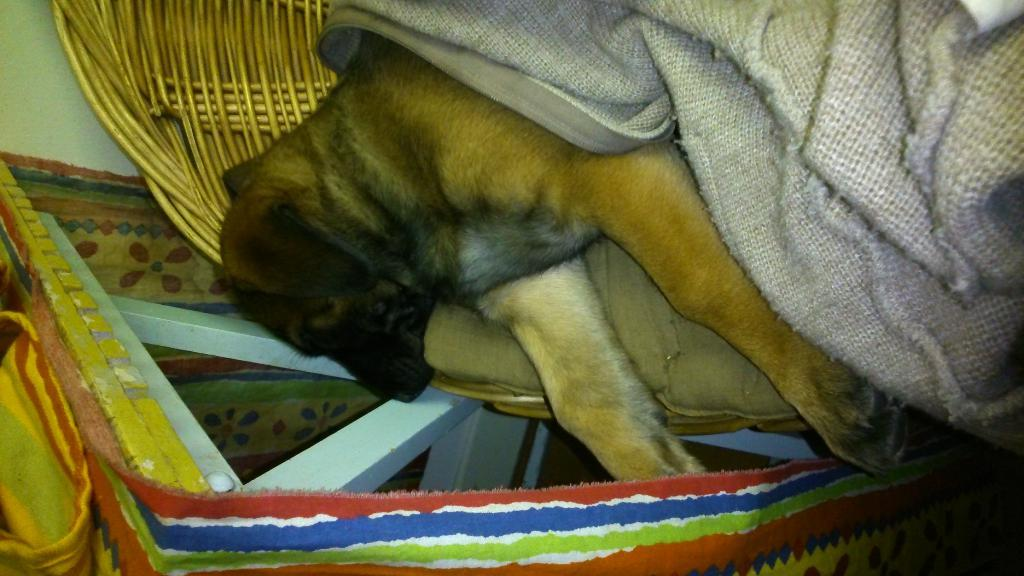What type of animal is in the image? There is a dog in the image. Where is the dog located? The dog is laying in a basket. What is covering the dog? There is a blanket above the dog. What is beside the basket? There is a table beside the basket. What is on the table? There is a cloth on the table. Are there any cobwebs visible in the image? There is no mention of cobwebs in the provided facts, and therefore we cannot determine their presence in the image. 